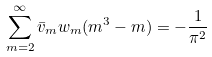Convert formula to latex. <formula><loc_0><loc_0><loc_500><loc_500>\sum _ { m = 2 } ^ { \infty } \bar { v } _ { m } w _ { m } ( m ^ { 3 } - m ) = - \frac { 1 } { \pi ^ { 2 } }</formula> 